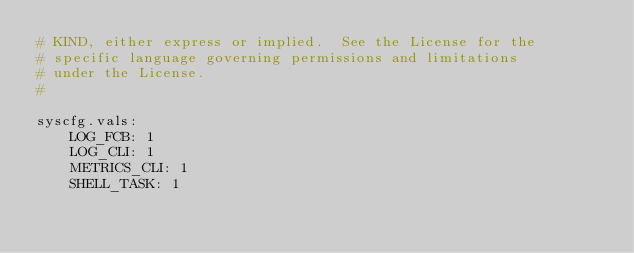<code> <loc_0><loc_0><loc_500><loc_500><_YAML_># KIND, either express or implied.  See the License for the
# specific language governing permissions and limitations
# under the License.
#

syscfg.vals:
    LOG_FCB: 1
    LOG_CLI: 1
    METRICS_CLI: 1
    SHELL_TASK: 1
</code> 